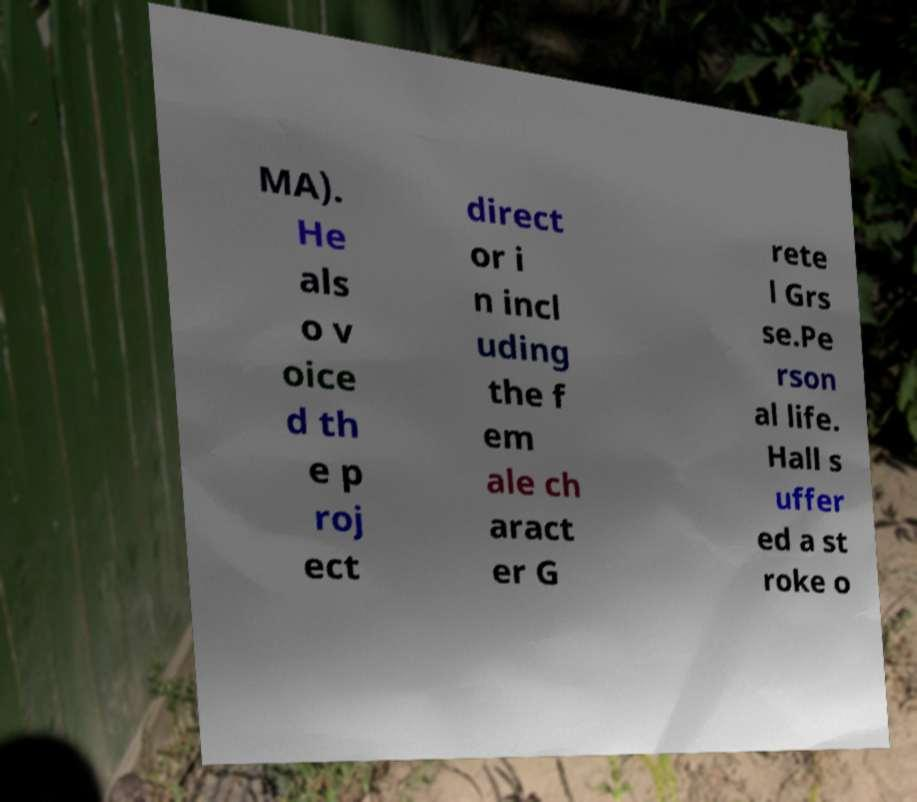There's text embedded in this image that I need extracted. Can you transcribe it verbatim? MA). He als o v oice d th e p roj ect direct or i n incl uding the f em ale ch aract er G rete l Grs se.Pe rson al life. Hall s uffer ed a st roke o 